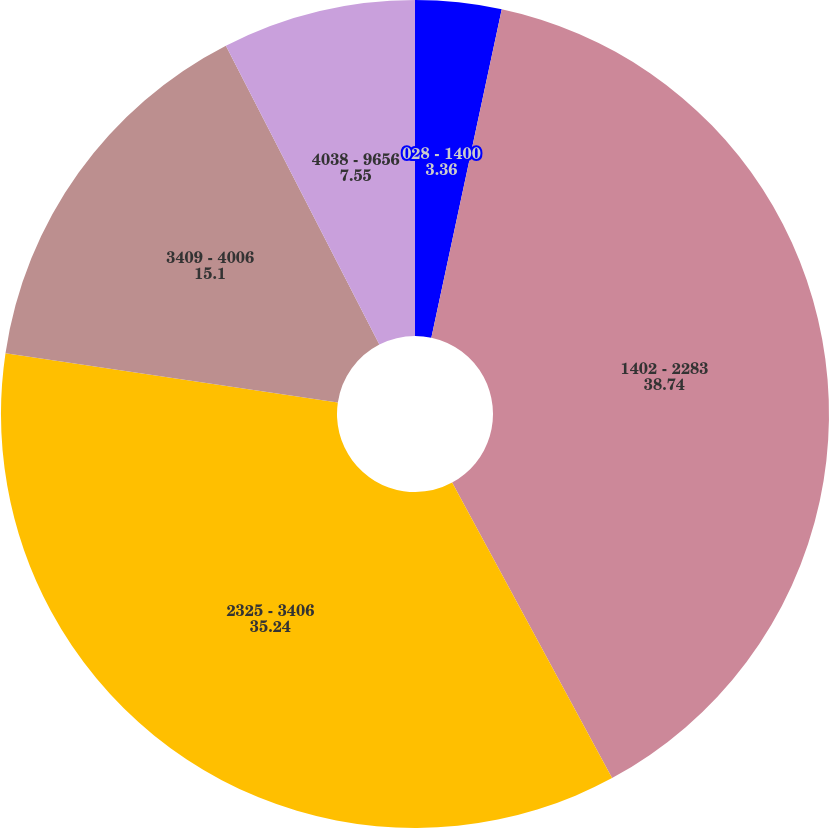Convert chart. <chart><loc_0><loc_0><loc_500><loc_500><pie_chart><fcel>028 - 1400<fcel>1402 - 2283<fcel>2325 - 3406<fcel>3409 - 4006<fcel>4038 - 9656<nl><fcel>3.36%<fcel>38.74%<fcel>35.24%<fcel>15.1%<fcel>7.55%<nl></chart> 